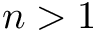Convert formula to latex. <formula><loc_0><loc_0><loc_500><loc_500>n > 1</formula> 